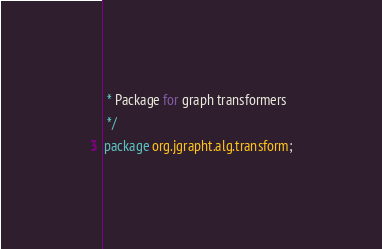<code> <loc_0><loc_0><loc_500><loc_500><_Java_> * Package for graph transformers
 */
package org.jgrapht.alg.transform;
</code> 